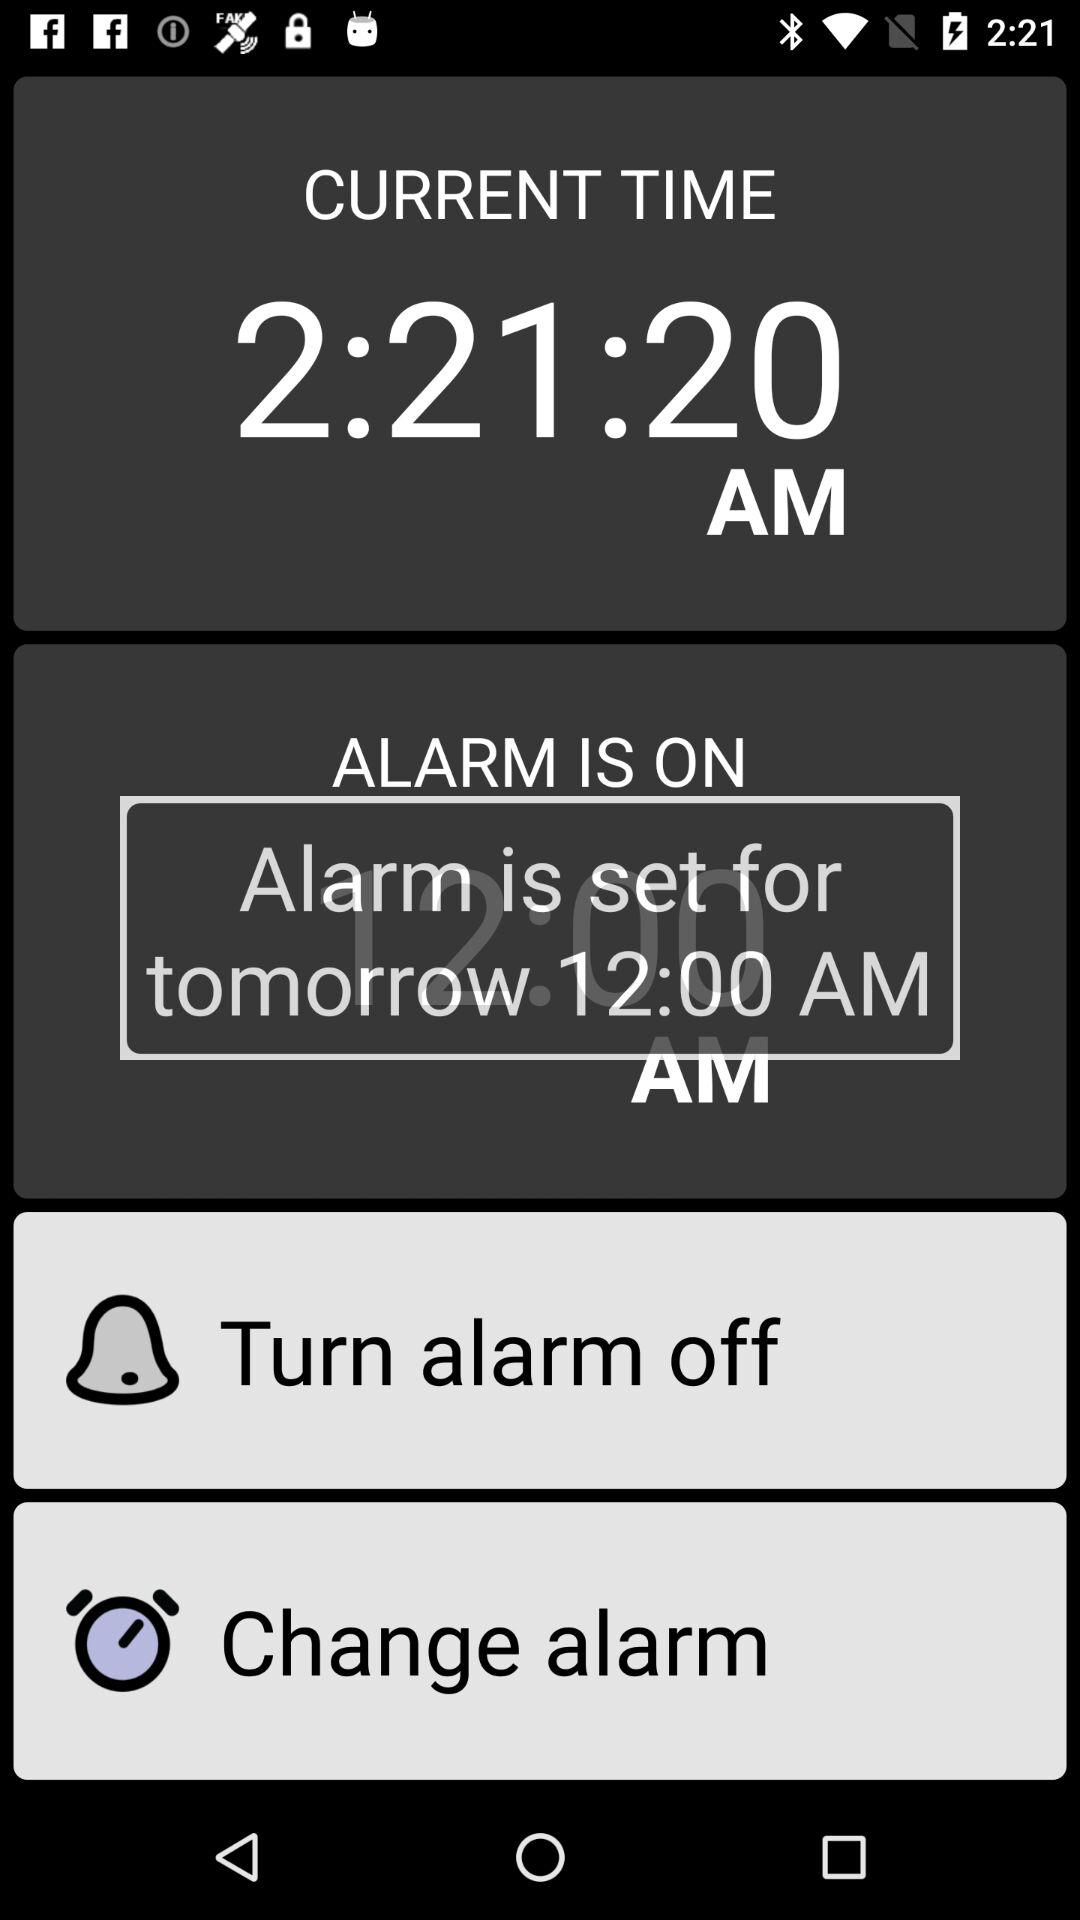What is the current time? The current time is 2:21:20 a.m. 